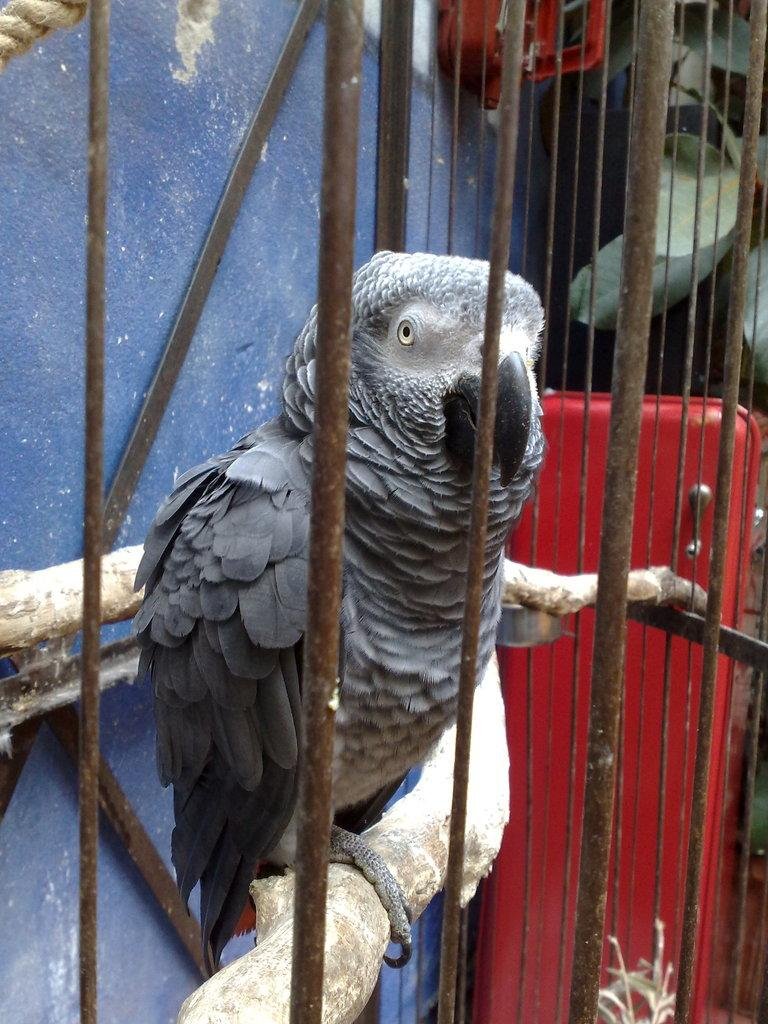What type of animal can be seen in the image? There is a bird in the image. What is the bird standing on? The bird is standing on a wooden stick. How is the wooden stick arranged in the image? The wooden stick is arranged in a cage. What colors can be seen in the background of the image? There is a blue color wall and a red color object in the background of the image. What else can be seen in the background of the image? There are other objects in the background of the image. What type of pie is being served to the bird in the image? There is no pie present in the image; the bird is standing on a wooden stick arranged in a cage. 